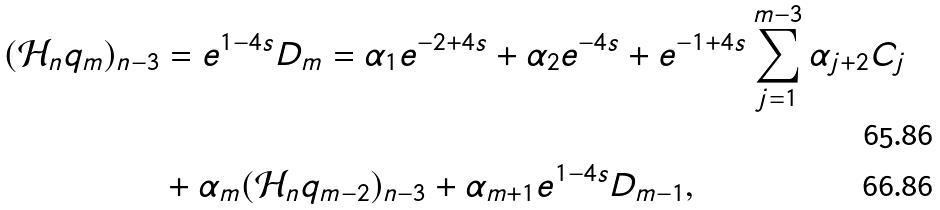Convert formula to latex. <formula><loc_0><loc_0><loc_500><loc_500>( \mathcal { H } _ { n } q _ { m } ) _ { n - 3 } & = e ^ { 1 - 4 s } D _ { m } = \alpha _ { 1 } e ^ { - 2 + 4 s } + \alpha _ { 2 } e ^ { - 4 s } + e ^ { - 1 + 4 s } \sum _ { j = 1 } ^ { m - 3 } \alpha _ { j + 2 } C _ { j } \\ & + \alpha _ { m } ( \mathcal { H } _ { n } q _ { m - 2 } ) _ { n - 3 } + \alpha _ { m + 1 } e ^ { 1 - 4 s } D _ { m - 1 } ,</formula> 